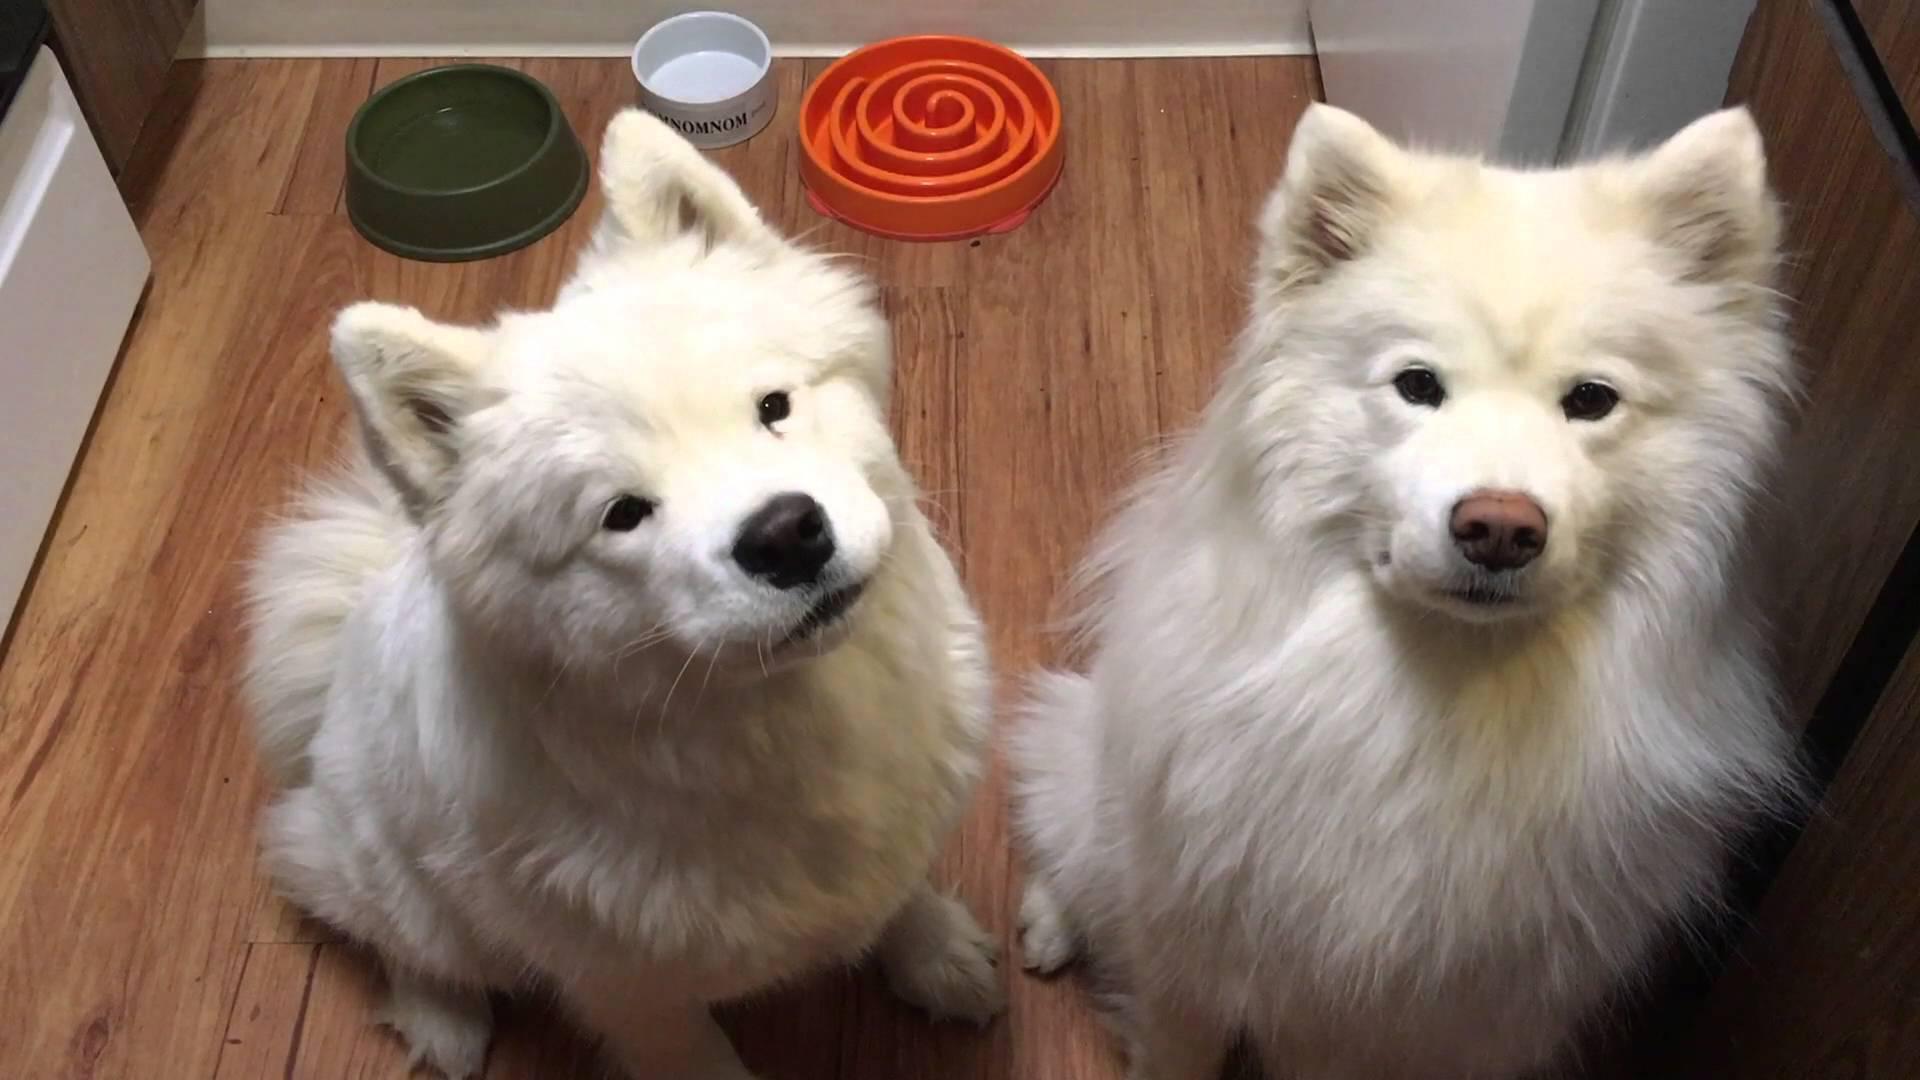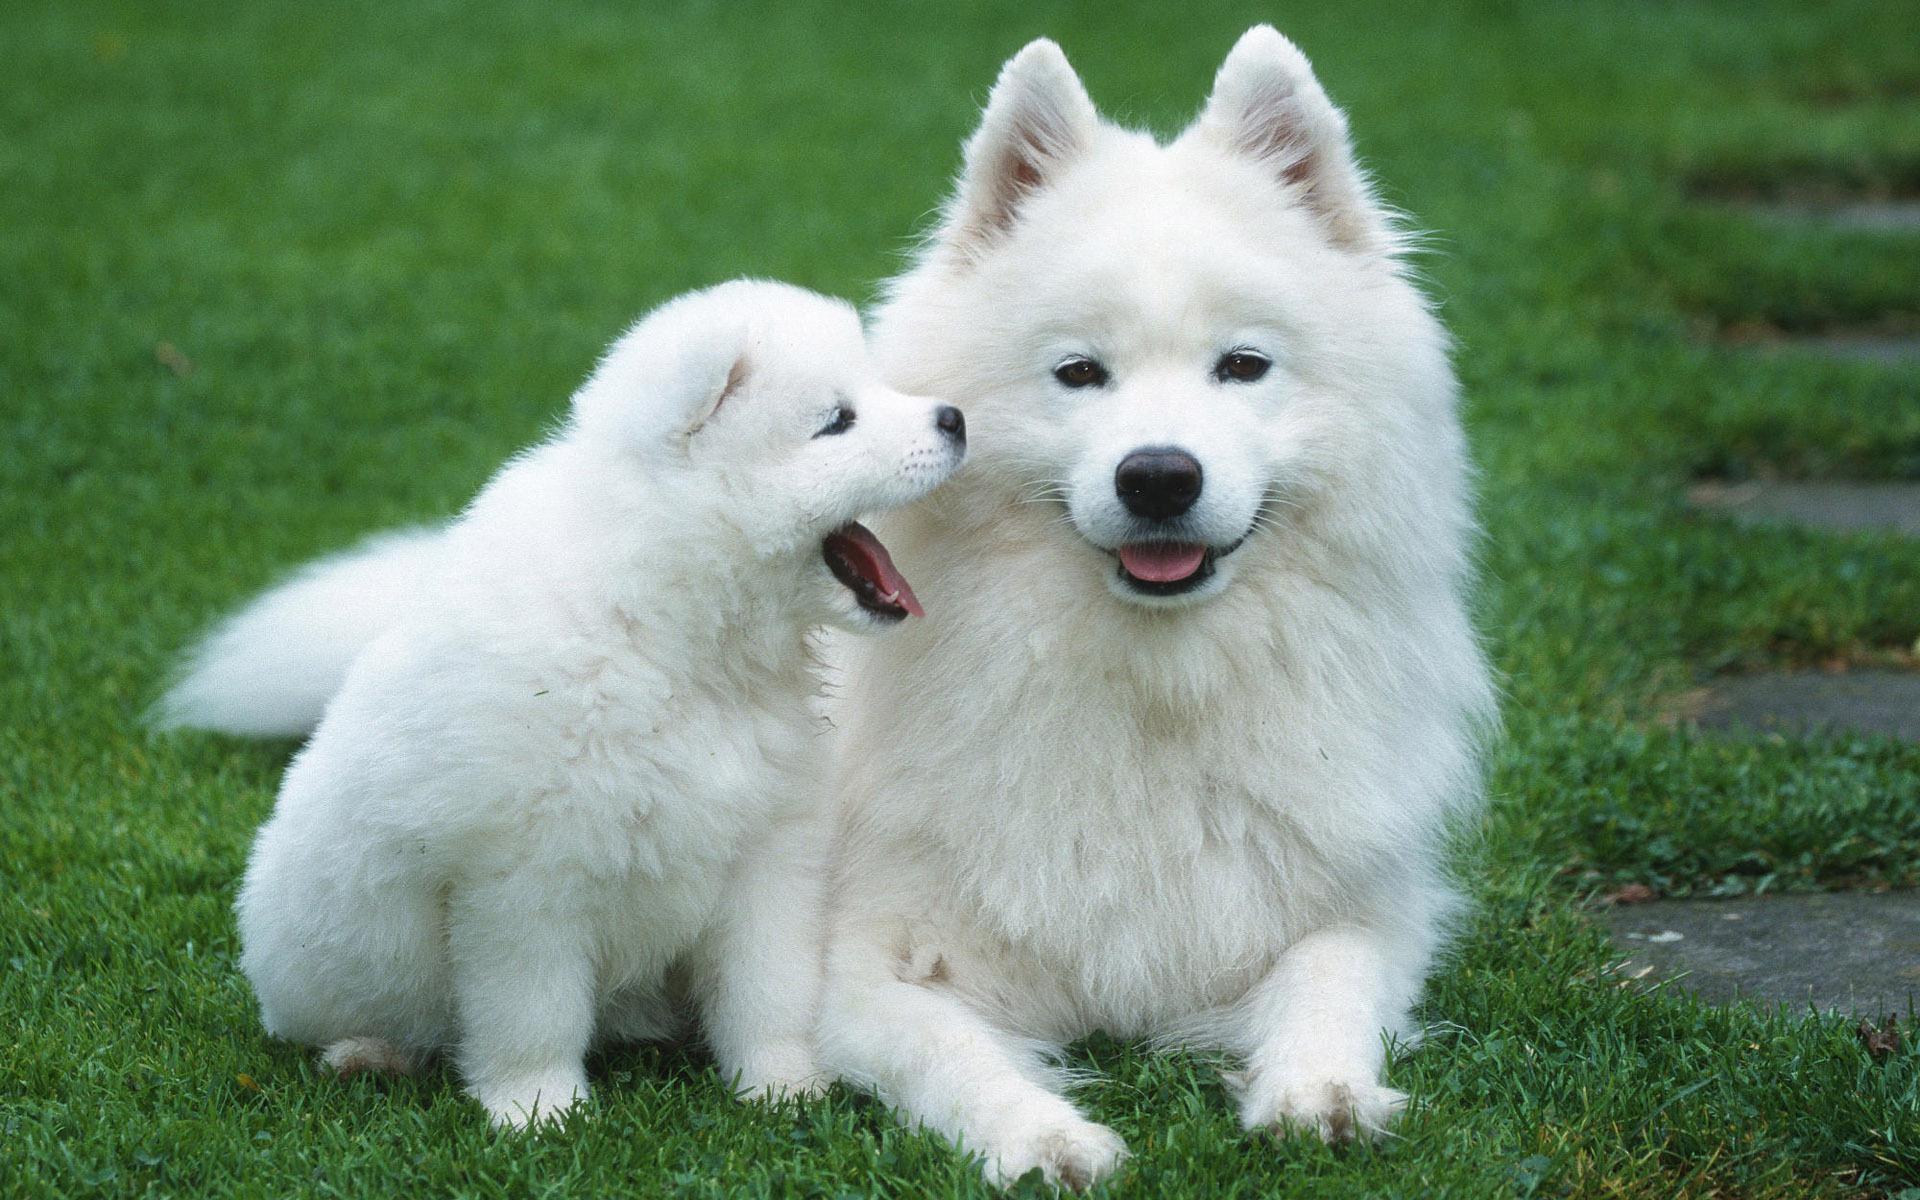The first image is the image on the left, the second image is the image on the right. Given the left and right images, does the statement "An image shows a young white dog next to a reclining large white dog on bright green grass." hold true? Answer yes or no. Yes. The first image is the image on the left, the second image is the image on the right. For the images displayed, is the sentence "There are no more then two white dogs." factually correct? Answer yes or no. No. 